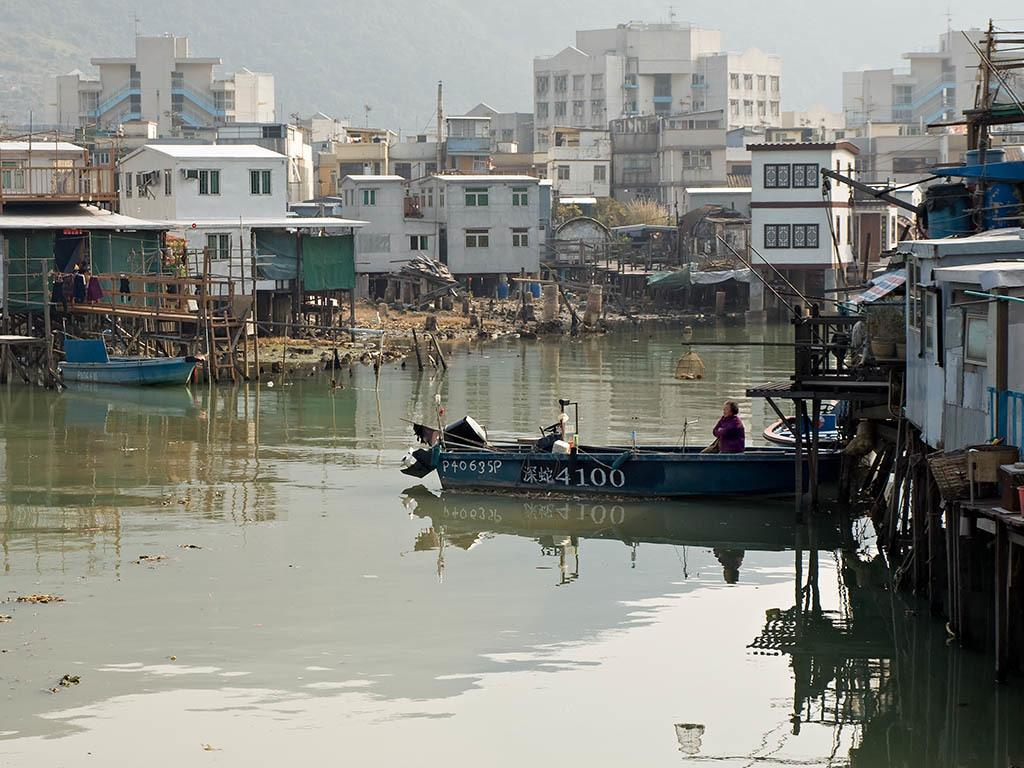What is the main subject of the image? The main subject of the image is a boat. Where is the boat located? The boat is on the water. What can be seen on either side of the water? There are buildings on either side of the water. What is visible in the background of the image? There are houses and a hill visible in the background. What type of teeth can be seen on the boat in the image? There are no teeth visible on the boat in the image. How many clams are present on the boat in the image? There are no clams present on the boat in the image. 